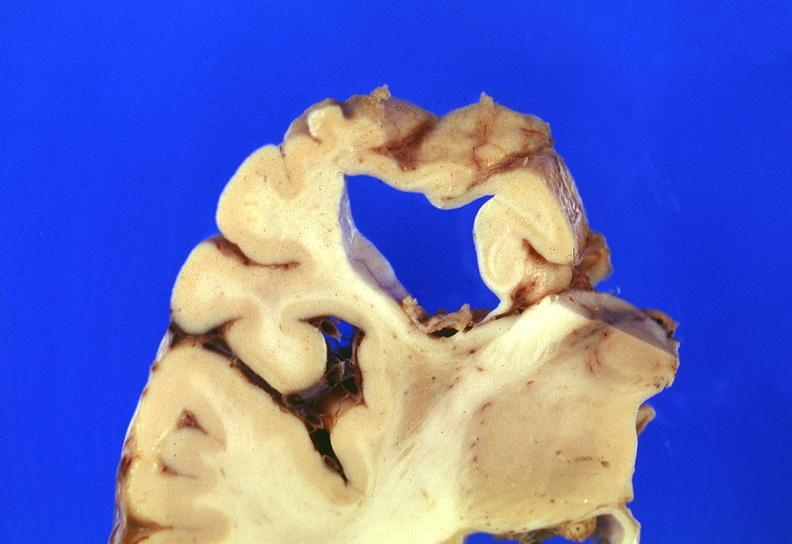does this image show brain, frontal lobe atrophy, pick 's disease?
Answer the question using a single word or phrase. Yes 